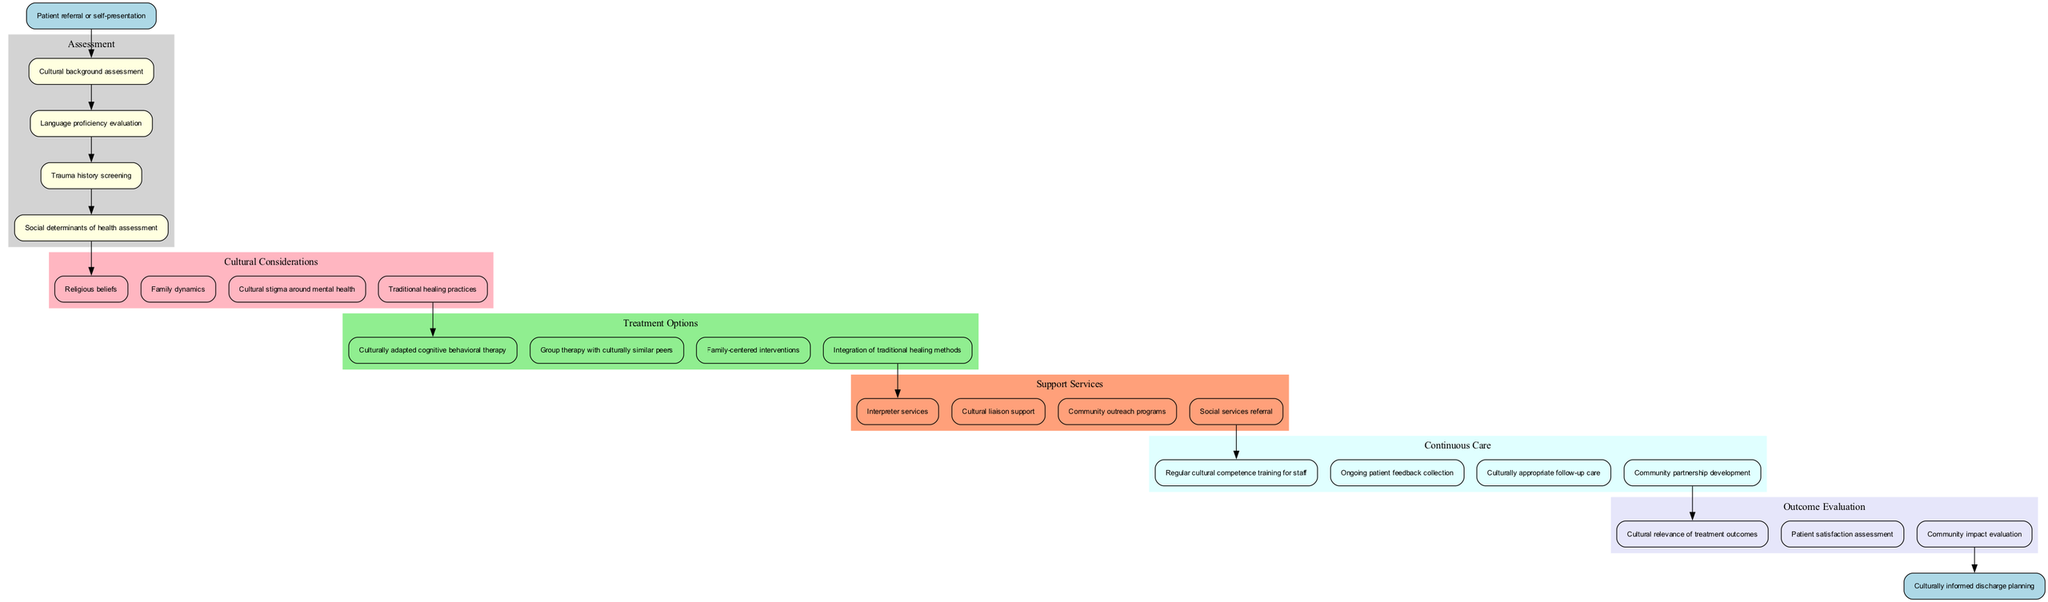What is the start point of the clinical pathway? The start point, as indicated in the diagram, is the first node connected to the subsequent assessment steps. It states "Patient referral or self-presentation".
Answer: Patient referral or self-presentation How many cultural considerations are listed? The diagram outlines four distinct cultural considerations. By counting the entries under the "Cultural Considerations" section, we find there are indeed four listed.
Answer: 4 What follows after the trauma history screening in the pathway? The next node after "Trauma history screening", listed in the assessment steps, is "Social determinants of health assessment", indicating the step following it in the clinical pathway.
Answer: Social determinants of health assessment Which treatment option emphasizes family involvement? Among the treatment options provided, "Family-centered interventions" specifically highlights the inclusion of family in the treatment plan, which is aimed at culturally sensitive care.
Answer: Family-centered interventions What are the support services available after the treatment options? The diagram indicates that "Interpreter services", "Cultural liaison support", "Community outreach programs", and "Social services referral" are all categorized as available support services following the treatment options.
Answer: Interpreter services, Cultural liaison support, Community outreach programs, Social services referral How is continuous care maintained according to the pathway? Continuous care is maintained through several methods, including "Regular cultural competence training for staff" and "Ongoing patient feedback collection" among others, which depict a commitment to cultural sensitivity in ongoing care.
Answer: Regular cultural competence training for staff, Ongoing patient feedback collection What indicates the end point of the clinical pathway? The end point is marked clearly in the diagram as "Culturally informed discharge planning", which signifies the completion of the clinical pathway after treatment and evaluation.
Answer: Culturally informed discharge planning What connects the outcome evaluation back to the treatment options? The final outcome evaluations are linked to the treatment options through a direct edge that shows the progression of care, implying that treatment effectiveness impacts the evaluation of overall outcomes.
Answer: Direct edge from treatment options to outcome evaluation 